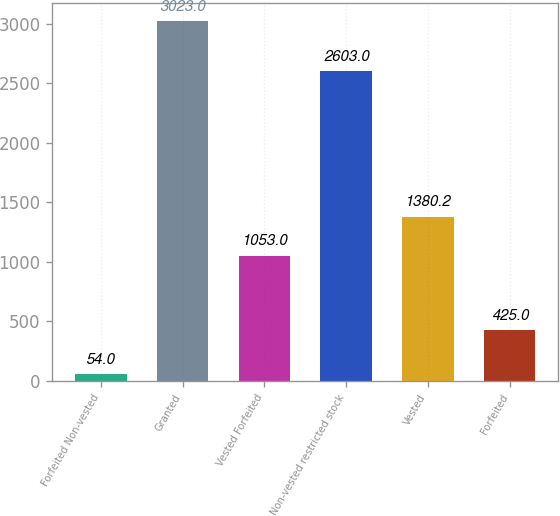Convert chart to OTSL. <chart><loc_0><loc_0><loc_500><loc_500><bar_chart><fcel>Forfeited Non-vested<fcel>Granted<fcel>Vested Forfeited<fcel>Non-vested restricted stock<fcel>Vested<fcel>Forfeited<nl><fcel>54<fcel>3023<fcel>1053<fcel>2603<fcel>1380.2<fcel>425<nl></chart> 